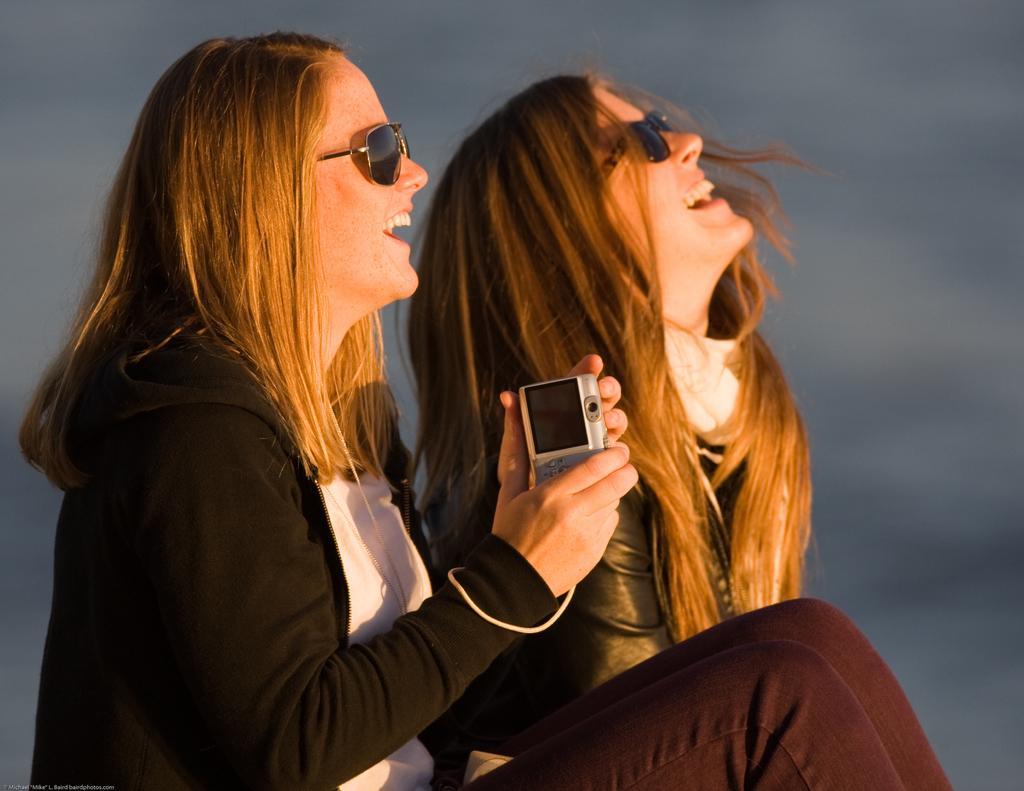How would you summarize this image in a sentence or two? In the middle of the image two women are sitting and smiling and she is holding a electronic device. 